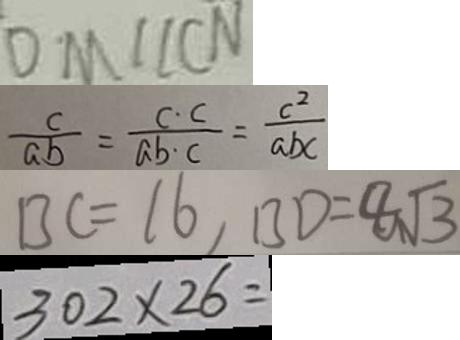Convert formula to latex. <formula><loc_0><loc_0><loc_500><loc_500>D M / / C N 
 \frac { c } { a b } = \frac { c \cdot c } { a b \cdot c } = \frac { c ^ { 2 } } { a b c } 
 B C = 1 6 , B D = 8 \sqrt { 3 } 
 3 0 2 \times 2 6 =</formula> 